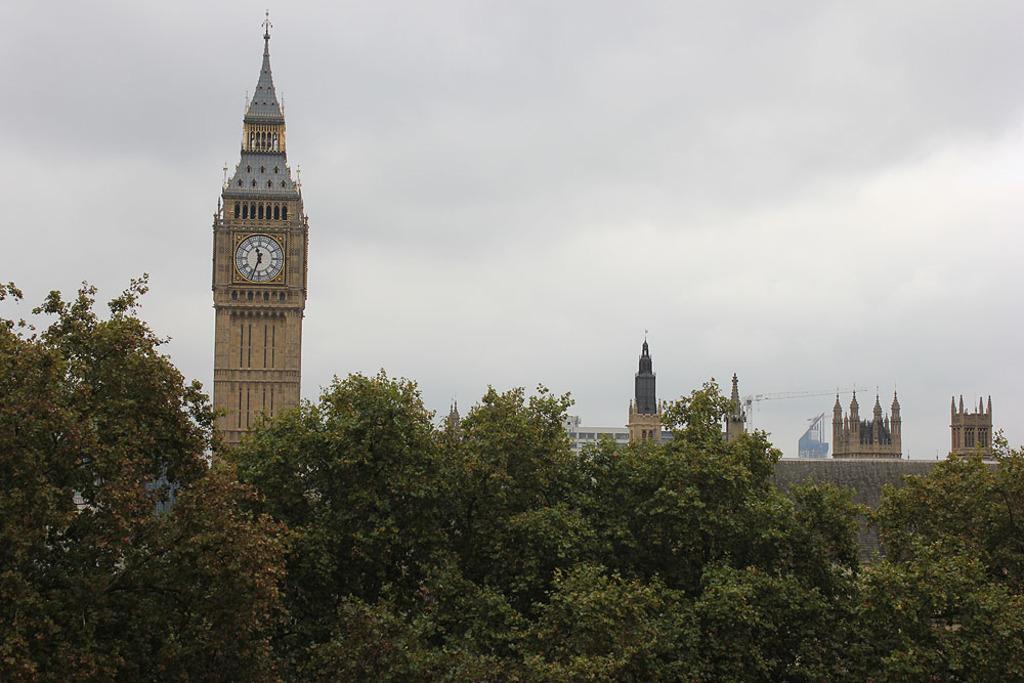Can you describe this image briefly? In this image we can see there are buildings, in front of that there are trees. In the background there is the sky. 